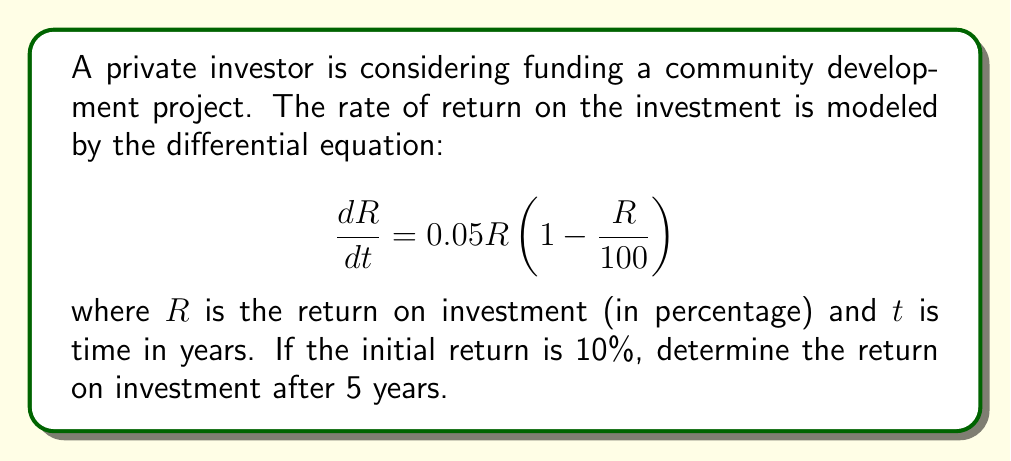Show me your answer to this math problem. To solve this problem, we need to use the separation of variables method for first-order differential equations.

1) First, let's separate the variables:

   $$\frac{dR}{R(1 - \frac{R}{100})} = 0.05dt$$

2) Integrate both sides:

   $$\int \frac{dR}{R(1 - \frac{R}{100})} = \int 0.05dt$$

3) The left side can be integrated using partial fractions:

   $$\int (\frac{1}{R} + \frac{1}{100-R})dR = 0.05t + C$$

4) Solving the integral:

   $$\ln|R| - \ln|100-R| = 0.05t + C$$

5) Simplify:

   $$\ln|\frac{R}{100-R}| = 0.05t + C$$

6) Apply the initial condition: At $t=0$, $R=10$:

   $$\ln|\frac{10}{90}| = C$$

7) Substitute this back into the general solution:

   $$\ln|\frac{R}{100-R}| = 0.05t + \ln|\frac{10}{90}|$$

8) Simplify:

   $$\frac{R}{100-R} = \frac{10}{90}e^{0.05t}$$

9) Solve for R:

   $$R = \frac{100}{1 + 9e^{-0.05t}}$$

10) Now, we can find R when t = 5:

    $$R = \frac{100}{1 + 9e^{-0.05(5)}} \approx 23.96$$

Therefore, after 5 years, the return on investment will be approximately 23.96%.
Answer: The return on investment after 5 years is approximately 23.96%. 